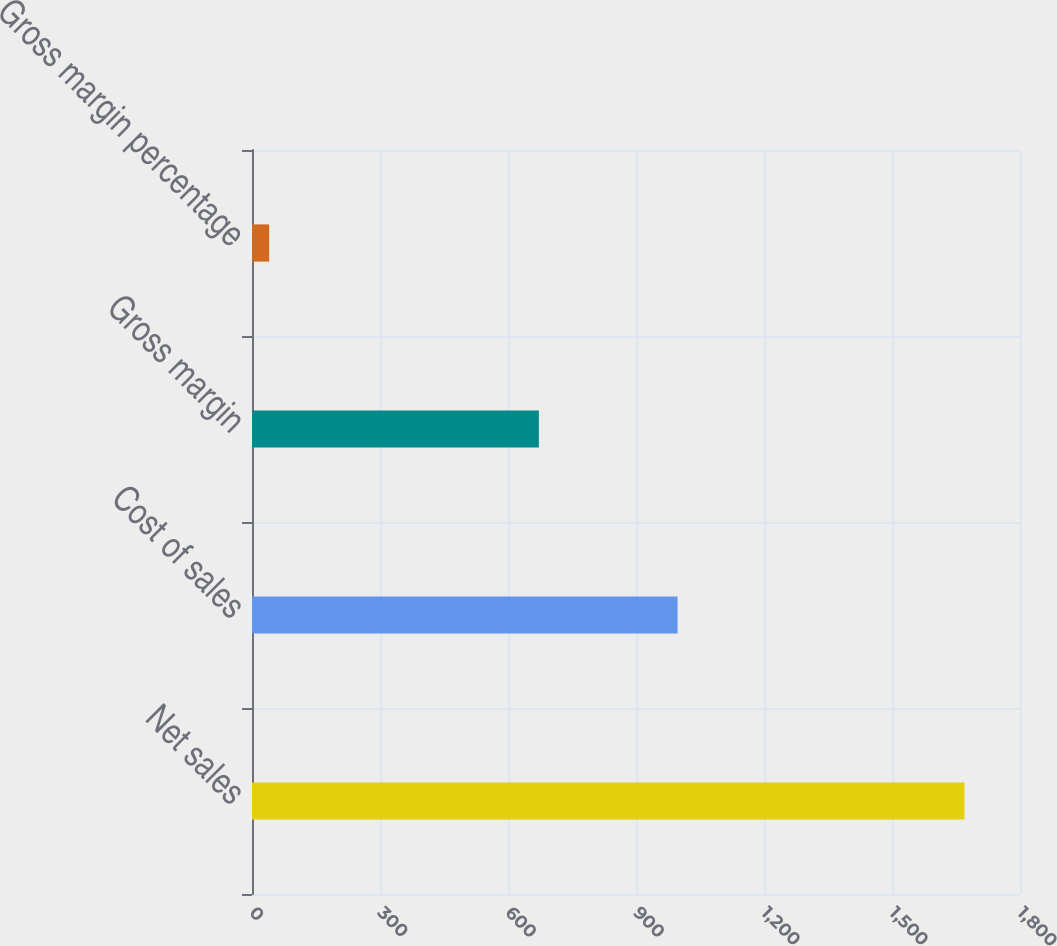Convert chart. <chart><loc_0><loc_0><loc_500><loc_500><bar_chart><fcel>Net sales<fcel>Cost of sales<fcel>Gross margin<fcel>Gross margin percentage<nl><fcel>1669.8<fcel>997.4<fcel>672.4<fcel>40.3<nl></chart> 